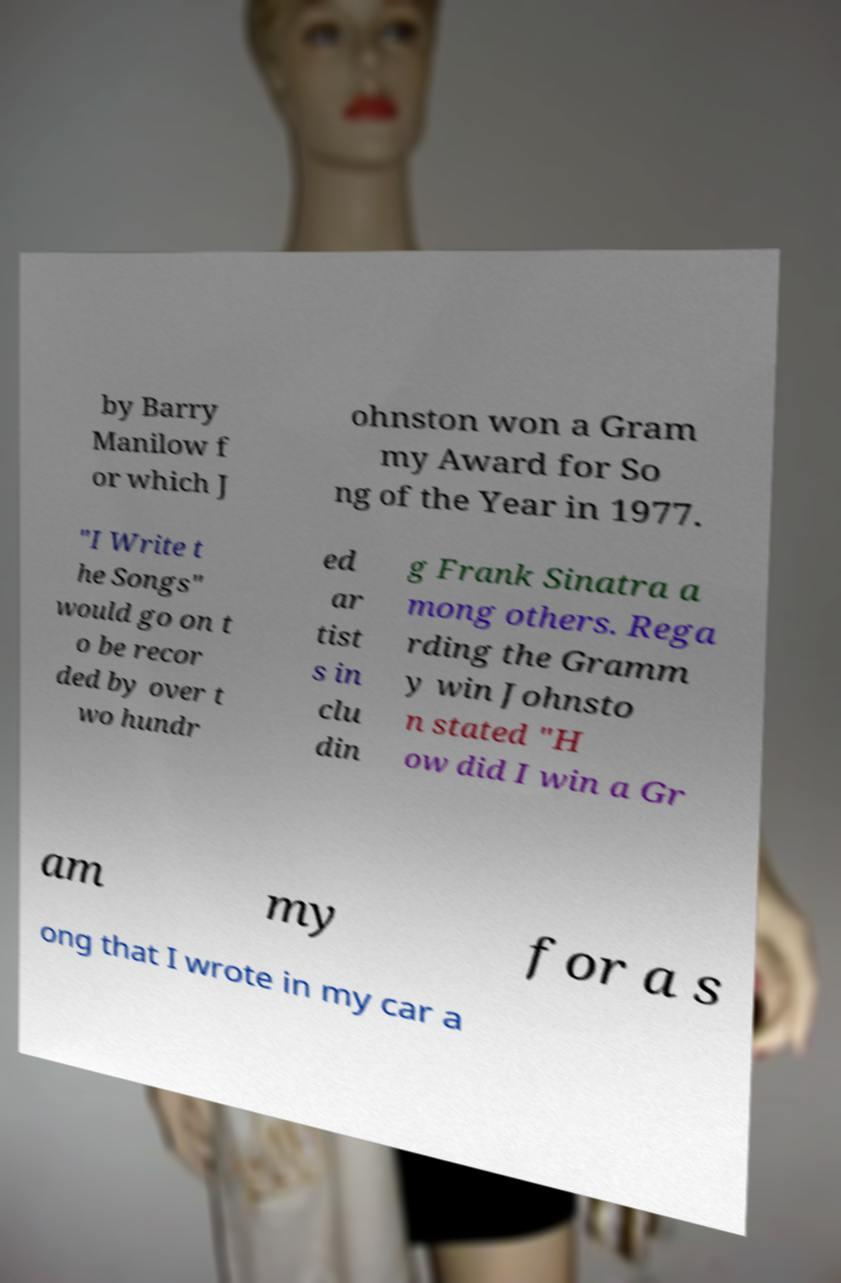What messages or text are displayed in this image? I need them in a readable, typed format. by Barry Manilow f or which J ohnston won a Gram my Award for So ng of the Year in 1977. "I Write t he Songs" would go on t o be recor ded by over t wo hundr ed ar tist s in clu din g Frank Sinatra a mong others. Rega rding the Gramm y win Johnsto n stated "H ow did I win a Gr am my for a s ong that I wrote in my car a 